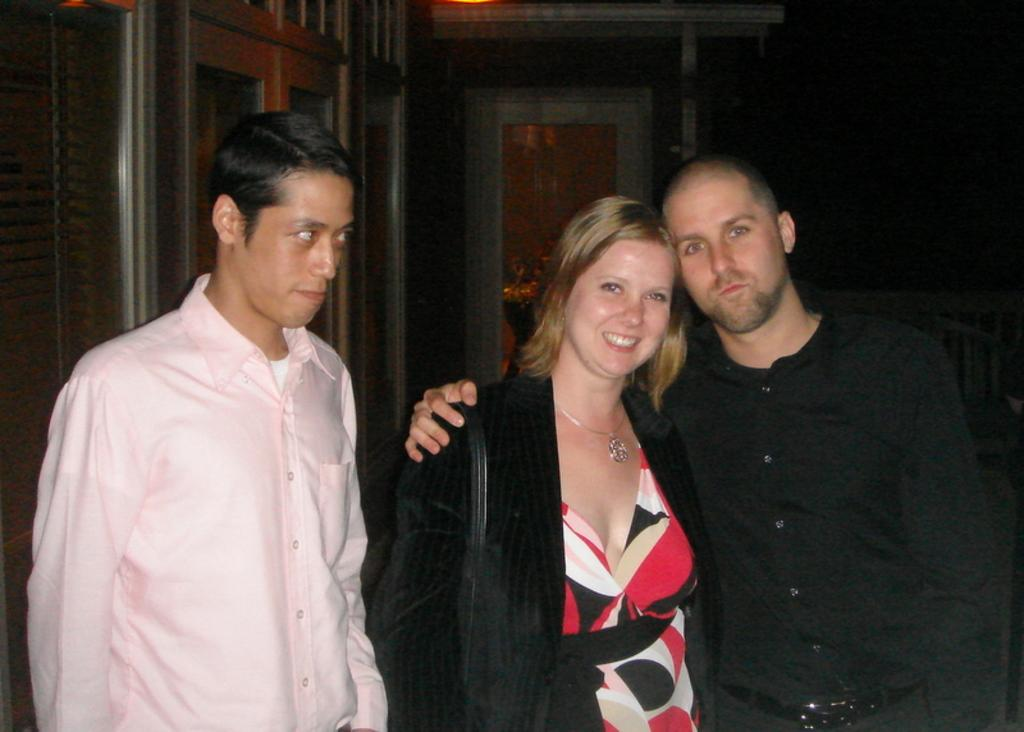How many people are present in the image? There are three people standing in the image. What is located at the backside of the image? There is a bench at the backside of the image. What can be seen in the background of the image? There is a door visible in the background of the image. What is the source of light in the room in the image? There is a light on top of the room in the image. What is the name of the person with the wound in the image? There is no person with a wound present in the image. 